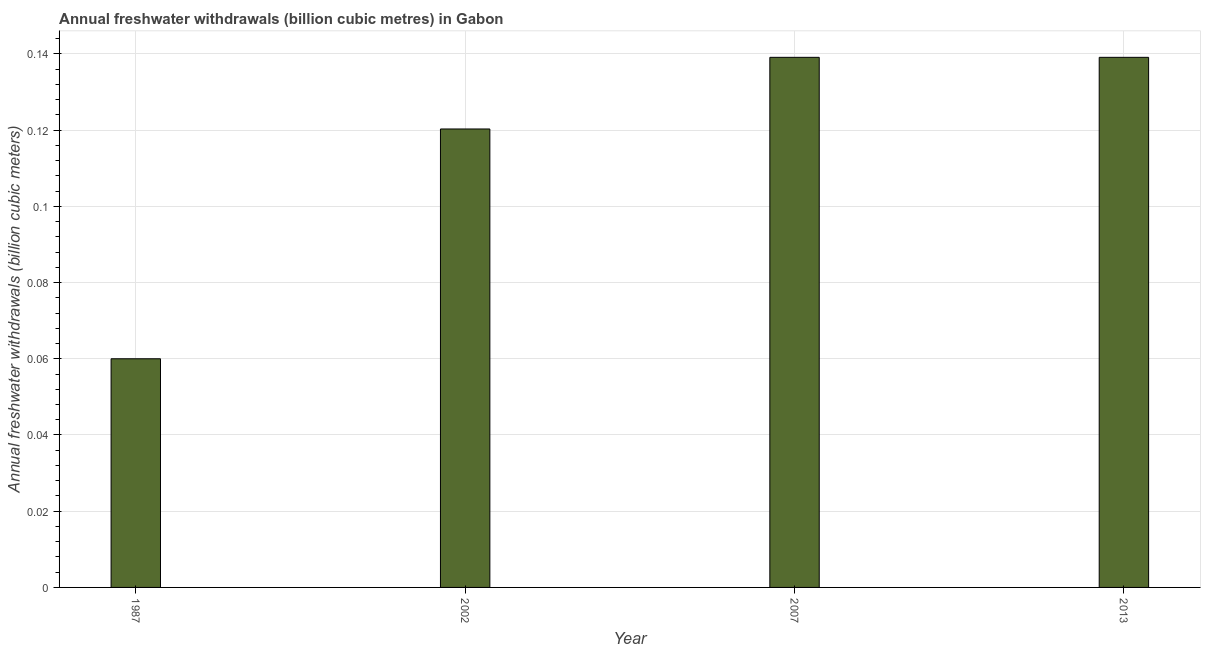Does the graph contain grids?
Provide a short and direct response. Yes. What is the title of the graph?
Ensure brevity in your answer.  Annual freshwater withdrawals (billion cubic metres) in Gabon. What is the label or title of the Y-axis?
Offer a terse response. Annual freshwater withdrawals (billion cubic meters). What is the annual freshwater withdrawals in 1987?
Make the answer very short. 0.06. Across all years, what is the maximum annual freshwater withdrawals?
Your response must be concise. 0.14. In which year was the annual freshwater withdrawals maximum?
Offer a terse response. 2007. In which year was the annual freshwater withdrawals minimum?
Offer a terse response. 1987. What is the sum of the annual freshwater withdrawals?
Give a very brief answer. 0.46. What is the difference between the annual freshwater withdrawals in 2002 and 2007?
Ensure brevity in your answer.  -0.02. What is the average annual freshwater withdrawals per year?
Offer a very short reply. 0.12. What is the median annual freshwater withdrawals?
Your response must be concise. 0.13. Do a majority of the years between 2002 and 1987 (inclusive) have annual freshwater withdrawals greater than 0.076 billion cubic meters?
Make the answer very short. No. What is the ratio of the annual freshwater withdrawals in 2007 to that in 2013?
Ensure brevity in your answer.  1. Is the annual freshwater withdrawals in 2007 less than that in 2013?
Your response must be concise. No. What is the difference between the highest and the lowest annual freshwater withdrawals?
Your answer should be compact. 0.08. Are all the bars in the graph horizontal?
Keep it short and to the point. No. How many years are there in the graph?
Your answer should be compact. 4. What is the Annual freshwater withdrawals (billion cubic meters) in 1987?
Ensure brevity in your answer.  0.06. What is the Annual freshwater withdrawals (billion cubic meters) in 2002?
Your answer should be compact. 0.12. What is the Annual freshwater withdrawals (billion cubic meters) of 2007?
Your answer should be very brief. 0.14. What is the Annual freshwater withdrawals (billion cubic meters) of 2013?
Offer a very short reply. 0.14. What is the difference between the Annual freshwater withdrawals (billion cubic meters) in 1987 and 2002?
Make the answer very short. -0.06. What is the difference between the Annual freshwater withdrawals (billion cubic meters) in 1987 and 2007?
Offer a very short reply. -0.08. What is the difference between the Annual freshwater withdrawals (billion cubic meters) in 1987 and 2013?
Your response must be concise. -0.08. What is the difference between the Annual freshwater withdrawals (billion cubic meters) in 2002 and 2007?
Give a very brief answer. -0.02. What is the difference between the Annual freshwater withdrawals (billion cubic meters) in 2002 and 2013?
Offer a terse response. -0.02. What is the ratio of the Annual freshwater withdrawals (billion cubic meters) in 1987 to that in 2002?
Provide a succinct answer. 0.5. What is the ratio of the Annual freshwater withdrawals (billion cubic meters) in 1987 to that in 2007?
Your response must be concise. 0.43. What is the ratio of the Annual freshwater withdrawals (billion cubic meters) in 1987 to that in 2013?
Provide a short and direct response. 0.43. What is the ratio of the Annual freshwater withdrawals (billion cubic meters) in 2002 to that in 2007?
Provide a succinct answer. 0.86. What is the ratio of the Annual freshwater withdrawals (billion cubic meters) in 2002 to that in 2013?
Offer a very short reply. 0.86. 